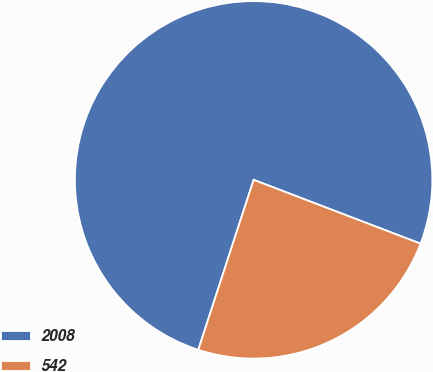<chart> <loc_0><loc_0><loc_500><loc_500><pie_chart><fcel>2008<fcel>542<nl><fcel>75.8%<fcel>24.2%<nl></chart> 